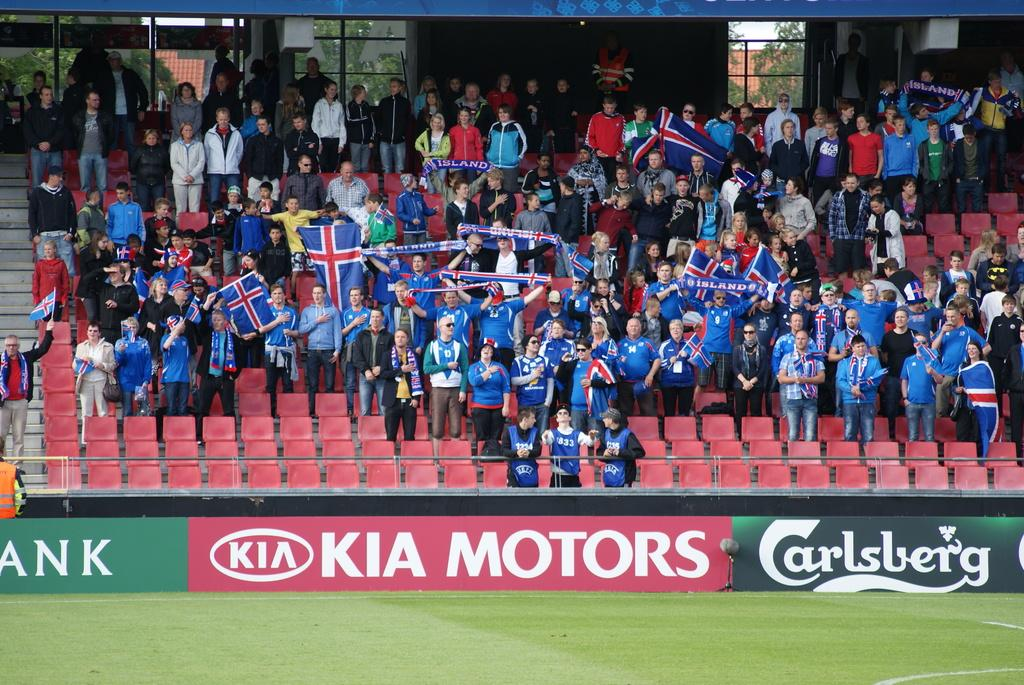What type of vegetation is visible in the image? There is grass in the image. What architectural feature can be seen in the image? There is a small wall in the image. What type of furniture is present in the image? There are chairs in the image. What is the purpose of the steps in the image? The steps in the image provide access to a higher level or area. What are the people in the image doing? There are people standing in the image, but their specific actions are not clear. What is located in the background of the image? There is a gate in the background of the image, and trees are behind the gate. What level of chess expertise do the people in the image possess? There is no indication of chess or any chess-related activity in the image. What type of calculator is being used by the people in the image? There is no calculator present in the image. 